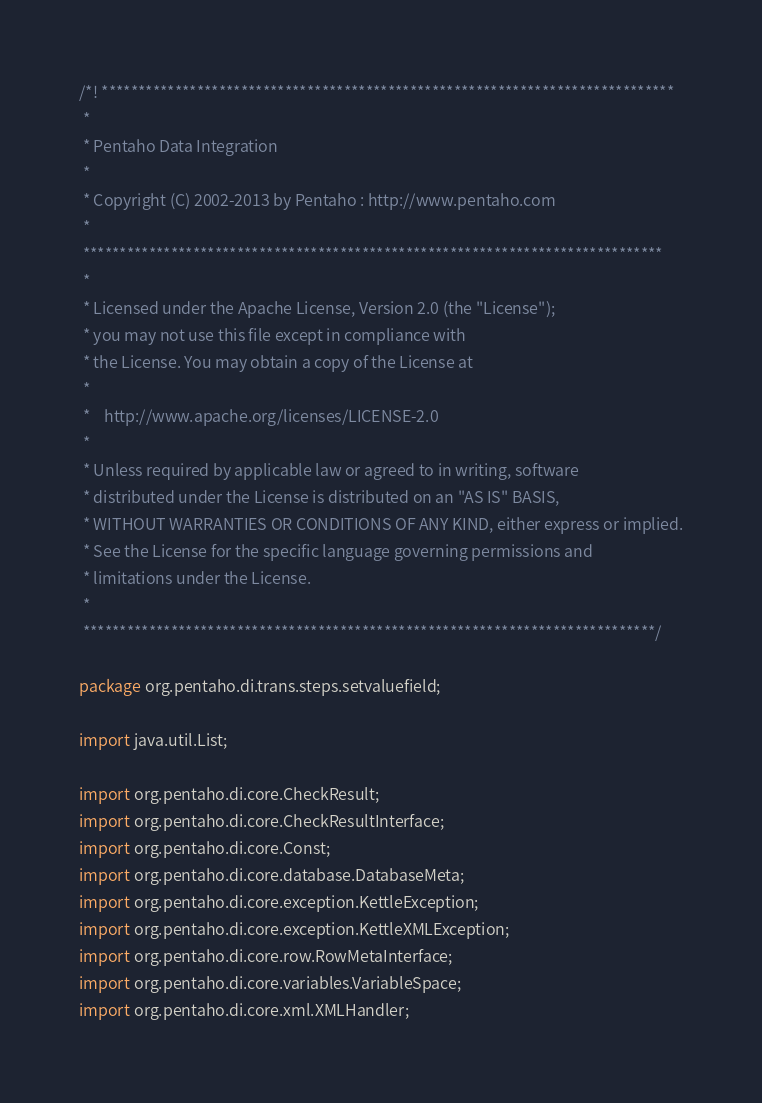<code> <loc_0><loc_0><loc_500><loc_500><_Java_>/*! ******************************************************************************
 *
 * Pentaho Data Integration
 *
 * Copyright (C) 2002-2013 by Pentaho : http://www.pentaho.com
 *
 *******************************************************************************
 *
 * Licensed under the Apache License, Version 2.0 (the "License");
 * you may not use this file except in compliance with
 * the License. You may obtain a copy of the License at
 *
 *    http://www.apache.org/licenses/LICENSE-2.0
 *
 * Unless required by applicable law or agreed to in writing, software
 * distributed under the License is distributed on an "AS IS" BASIS,
 * WITHOUT WARRANTIES OR CONDITIONS OF ANY KIND, either express or implied.
 * See the License for the specific language governing permissions and
 * limitations under the License.
 *
 ******************************************************************************/

package org.pentaho.di.trans.steps.setvaluefield;

import java.util.List;

import org.pentaho.di.core.CheckResult;
import org.pentaho.di.core.CheckResultInterface;
import org.pentaho.di.core.Const;
import org.pentaho.di.core.database.DatabaseMeta;
import org.pentaho.di.core.exception.KettleException;
import org.pentaho.di.core.exception.KettleXMLException;
import org.pentaho.di.core.row.RowMetaInterface;
import org.pentaho.di.core.variables.VariableSpace;
import org.pentaho.di.core.xml.XMLHandler;</code> 